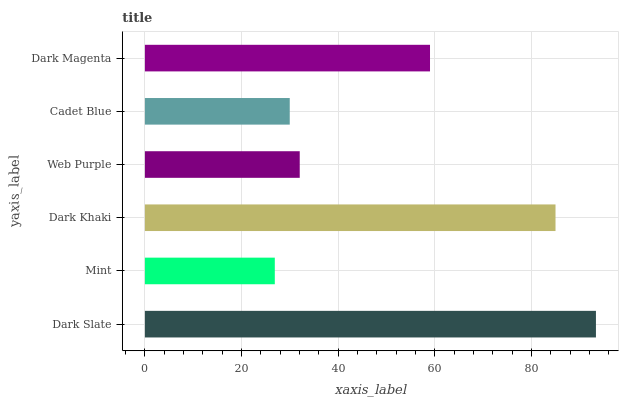Is Mint the minimum?
Answer yes or no. Yes. Is Dark Slate the maximum?
Answer yes or no. Yes. Is Dark Khaki the minimum?
Answer yes or no. No. Is Dark Khaki the maximum?
Answer yes or no. No. Is Dark Khaki greater than Mint?
Answer yes or no. Yes. Is Mint less than Dark Khaki?
Answer yes or no. Yes. Is Mint greater than Dark Khaki?
Answer yes or no. No. Is Dark Khaki less than Mint?
Answer yes or no. No. Is Dark Magenta the high median?
Answer yes or no. Yes. Is Web Purple the low median?
Answer yes or no. Yes. Is Web Purple the high median?
Answer yes or no. No. Is Dark Magenta the low median?
Answer yes or no. No. 